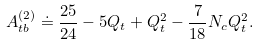<formula> <loc_0><loc_0><loc_500><loc_500>A _ { t b } ^ { ( 2 ) } \doteq \frac { 2 5 } { 2 4 } - 5 Q _ { t } + Q _ { t } ^ { 2 } - \frac { 7 } { 1 8 } N _ { c } Q _ { t } ^ { 2 } .</formula> 